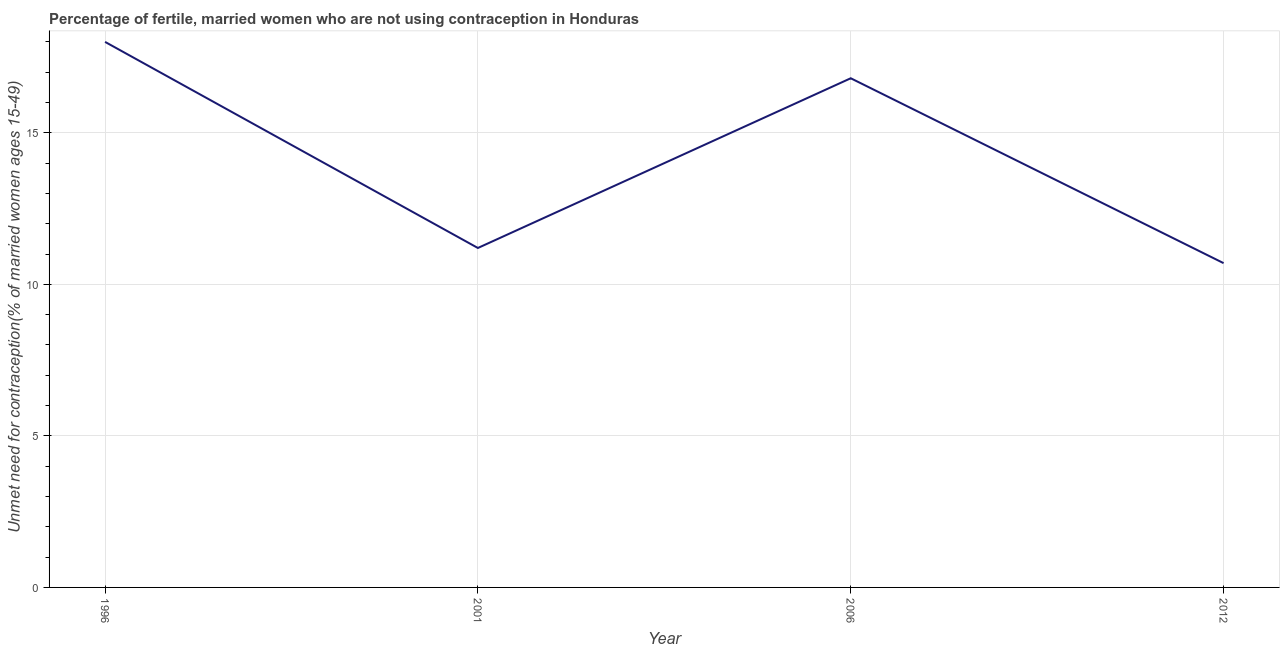In which year was the number of married women who are not using contraception minimum?
Provide a short and direct response. 2012. What is the sum of the number of married women who are not using contraception?
Make the answer very short. 56.7. What is the difference between the number of married women who are not using contraception in 2006 and 2012?
Keep it short and to the point. 6.1. What is the average number of married women who are not using contraception per year?
Offer a very short reply. 14.18. Do a majority of the years between 2001 and 1996 (inclusive) have number of married women who are not using contraception greater than 6 %?
Offer a very short reply. No. What is the ratio of the number of married women who are not using contraception in 1996 to that in 2001?
Your answer should be compact. 1.61. Is the number of married women who are not using contraception in 1996 less than that in 2001?
Your answer should be very brief. No. What is the difference between the highest and the second highest number of married women who are not using contraception?
Provide a succinct answer. 1.2. Is the sum of the number of married women who are not using contraception in 1996 and 2006 greater than the maximum number of married women who are not using contraception across all years?
Provide a short and direct response. Yes. What is the difference between the highest and the lowest number of married women who are not using contraception?
Your response must be concise. 7.3. In how many years, is the number of married women who are not using contraception greater than the average number of married women who are not using contraception taken over all years?
Keep it short and to the point. 2. How many years are there in the graph?
Keep it short and to the point. 4. What is the difference between two consecutive major ticks on the Y-axis?
Offer a very short reply. 5. What is the title of the graph?
Your response must be concise. Percentage of fertile, married women who are not using contraception in Honduras. What is the label or title of the Y-axis?
Keep it short and to the point.  Unmet need for contraception(% of married women ages 15-49). What is the  Unmet need for contraception(% of married women ages 15-49) of 1996?
Make the answer very short. 18. What is the  Unmet need for contraception(% of married women ages 15-49) in 2001?
Provide a short and direct response. 11.2. What is the  Unmet need for contraception(% of married women ages 15-49) in 2006?
Ensure brevity in your answer.  16.8. What is the  Unmet need for contraception(% of married women ages 15-49) in 2012?
Provide a succinct answer. 10.7. What is the difference between the  Unmet need for contraception(% of married women ages 15-49) in 2001 and 2006?
Offer a terse response. -5.6. What is the ratio of the  Unmet need for contraception(% of married women ages 15-49) in 1996 to that in 2001?
Offer a terse response. 1.61. What is the ratio of the  Unmet need for contraception(% of married women ages 15-49) in 1996 to that in 2006?
Your response must be concise. 1.07. What is the ratio of the  Unmet need for contraception(% of married women ages 15-49) in 1996 to that in 2012?
Make the answer very short. 1.68. What is the ratio of the  Unmet need for contraception(% of married women ages 15-49) in 2001 to that in 2006?
Provide a succinct answer. 0.67. What is the ratio of the  Unmet need for contraception(% of married women ages 15-49) in 2001 to that in 2012?
Your response must be concise. 1.05. What is the ratio of the  Unmet need for contraception(% of married women ages 15-49) in 2006 to that in 2012?
Offer a terse response. 1.57. 